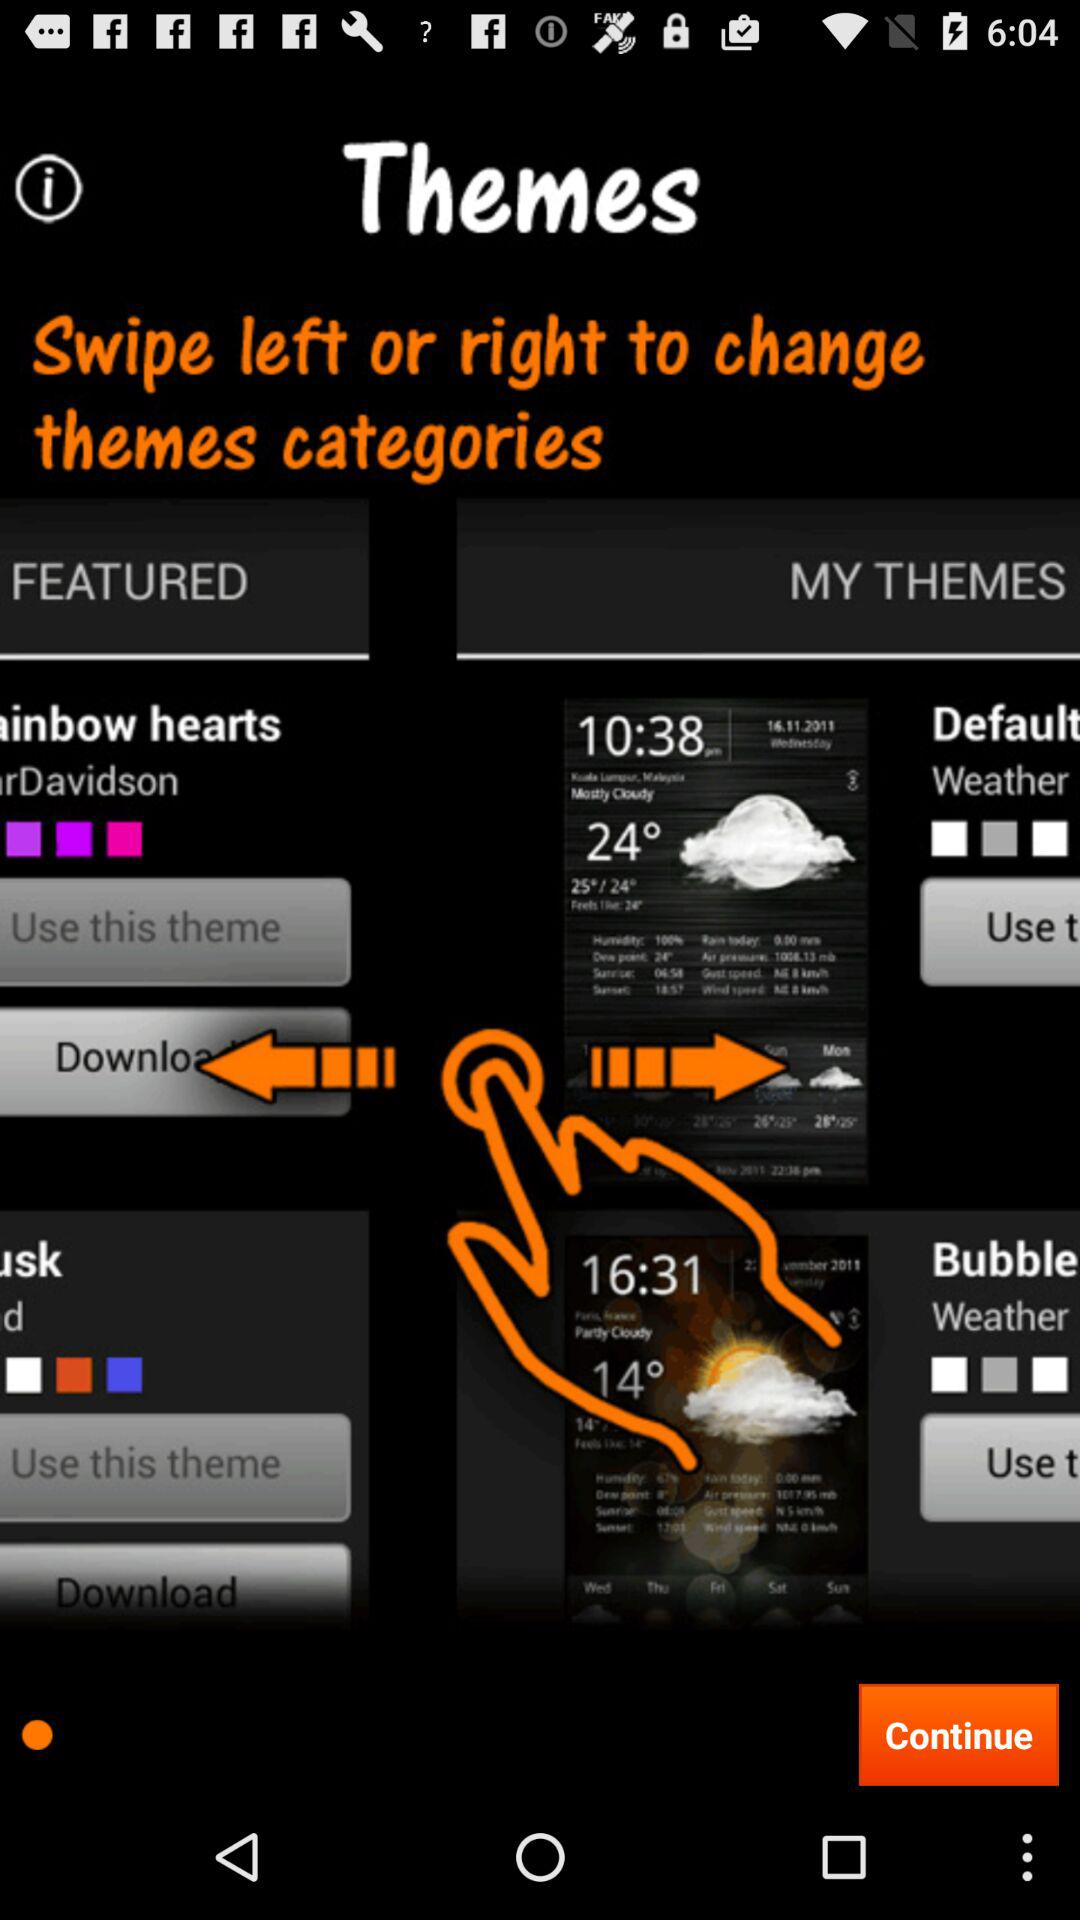How many themes are in the Featured category?
Answer the question using a single word or phrase. 2 